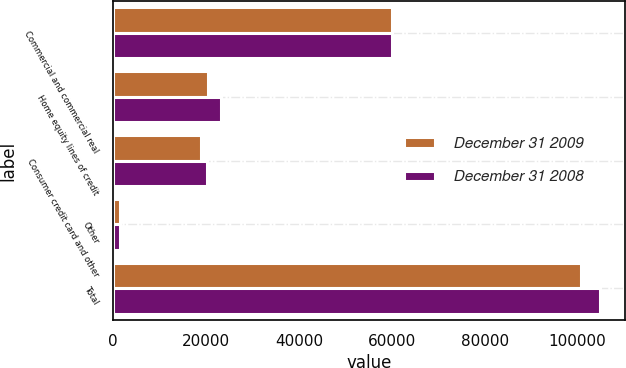Convert chart. <chart><loc_0><loc_0><loc_500><loc_500><stacked_bar_chart><ecel><fcel>Commercial and commercial real<fcel>Home equity lines of credit<fcel>Consumer credit card and other<fcel>Other<fcel>Total<nl><fcel>December 31 2009<fcel>60143<fcel>20367<fcel>18800<fcel>1485<fcel>100795<nl><fcel>December 31 2008<fcel>60020<fcel>23195<fcel>20207<fcel>1466<fcel>104888<nl></chart> 